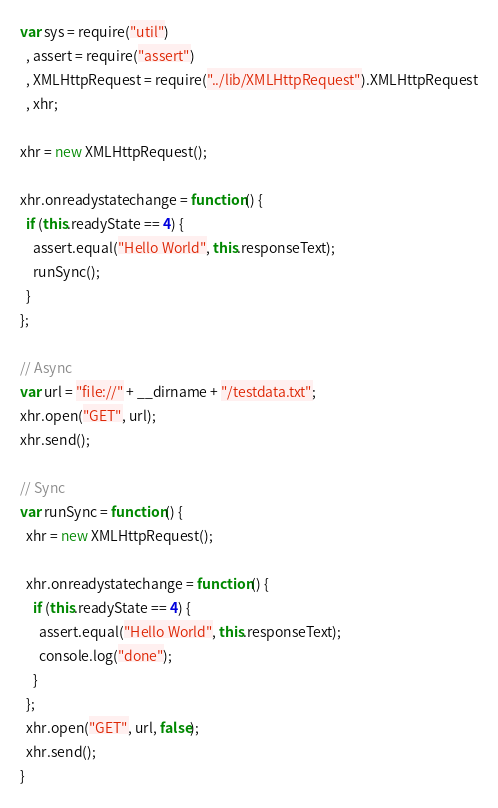Convert code to text. <code><loc_0><loc_0><loc_500><loc_500><_JavaScript_>var sys = require("util")
  , assert = require("assert")
  , XMLHttpRequest = require("../lib/XMLHttpRequest").XMLHttpRequest
  , xhr;

xhr = new XMLHttpRequest();

xhr.onreadystatechange = function() {
  if (this.readyState == 4) {
    assert.equal("Hello World", this.responseText);
    runSync();
  }
};

// Async
var url = "file://" + __dirname + "/testdata.txt";
xhr.open("GET", url);
xhr.send();

// Sync
var runSync = function() {
  xhr = new XMLHttpRequest();

  xhr.onreadystatechange = function() {
    if (this.readyState == 4) {
      assert.equal("Hello World", this.responseText);
      console.log("done");
    }
  };
  xhr.open("GET", url, false);
  xhr.send();
}
</code> 